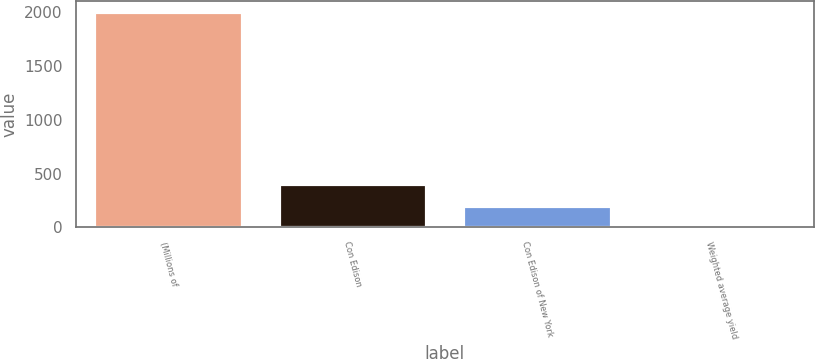Convert chart. <chart><loc_0><loc_0><loc_500><loc_500><bar_chart><fcel>(Millions of<fcel>Con Edison<fcel>Con Edison of New York<fcel>Weighted average yield<nl><fcel>2004<fcel>402.56<fcel>202.38<fcel>2.2<nl></chart> 